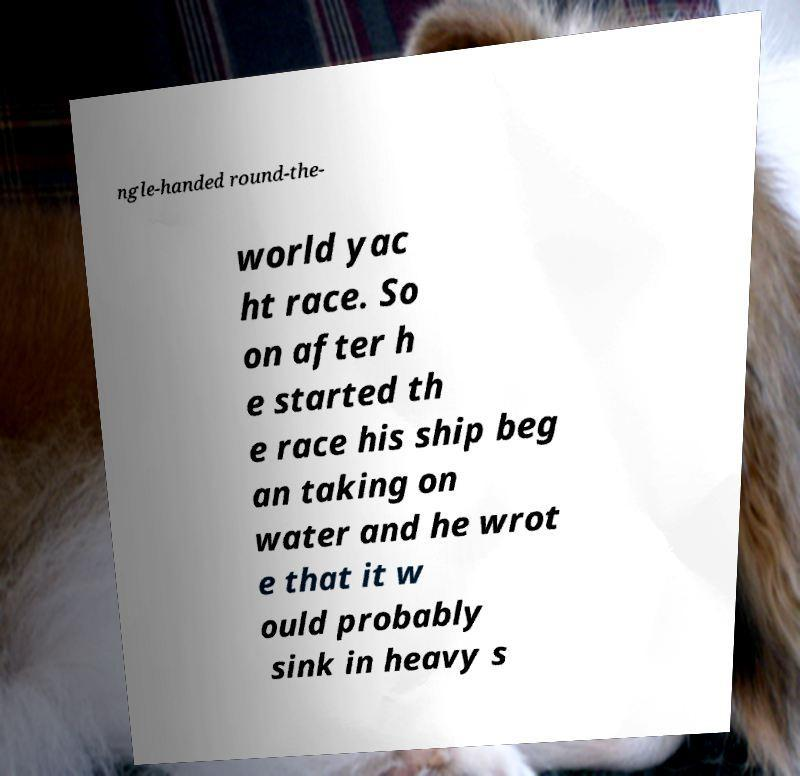Can you read and provide the text displayed in the image?This photo seems to have some interesting text. Can you extract and type it out for me? ngle-handed round-the- world yac ht race. So on after h e started th e race his ship beg an taking on water and he wrot e that it w ould probably sink in heavy s 